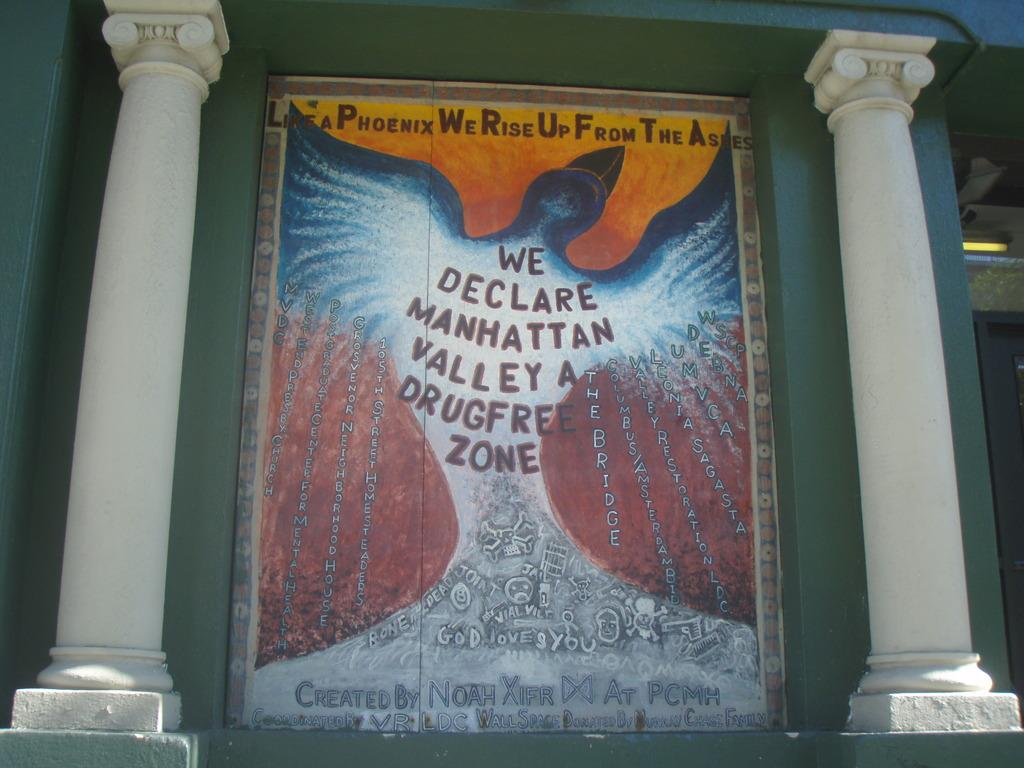<image>
Summarize the visual content of the image. a mural saying we declare manhatten valley a drug free zone 